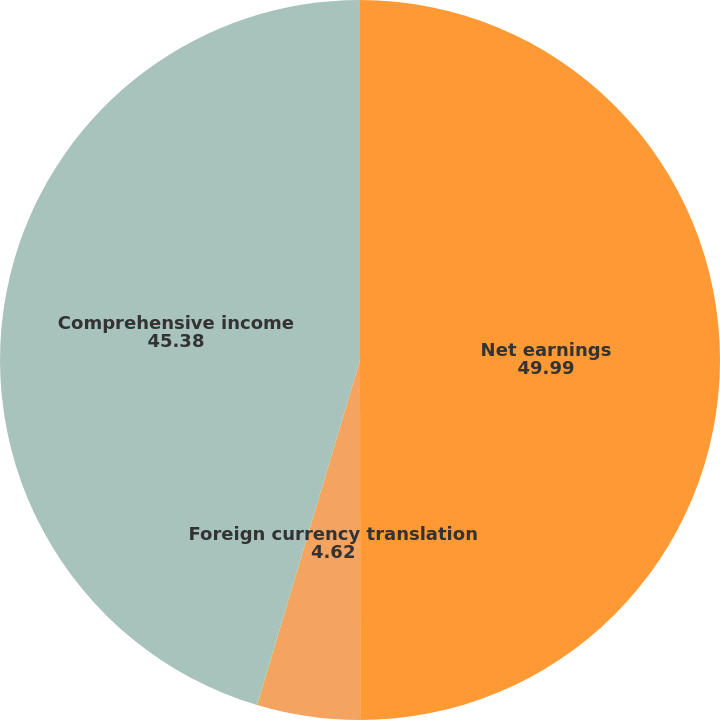Convert chart. <chart><loc_0><loc_0><loc_500><loc_500><pie_chart><fcel>Net earnings<fcel>Foreign currency translation<fcel>Change in marketable<fcel>Comprehensive income<nl><fcel>49.99%<fcel>4.62%<fcel>0.01%<fcel>45.38%<nl></chart> 